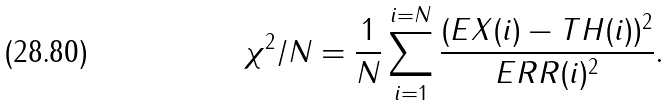<formula> <loc_0><loc_0><loc_500><loc_500>\chi ^ { 2 } / N = \frac { 1 } { N } \sum _ { i = 1 } ^ { i = N } \frac { ( E X ( i ) - T H ( i ) ) ^ { 2 } } { E R R ( i ) ^ { 2 } } .</formula> 